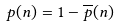Convert formula to latex. <formula><loc_0><loc_0><loc_500><loc_500>p ( n ) = 1 - \overline { p } ( n )</formula> 